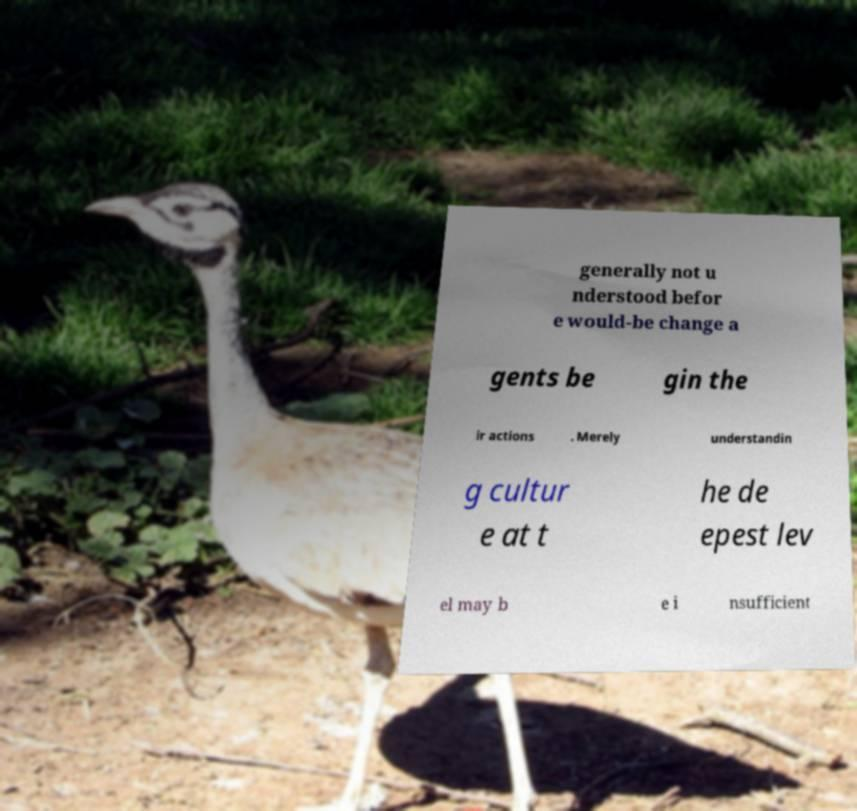For documentation purposes, I need the text within this image transcribed. Could you provide that? generally not u nderstood befor e would-be change a gents be gin the ir actions . Merely understandin g cultur e at t he de epest lev el may b e i nsufficient 